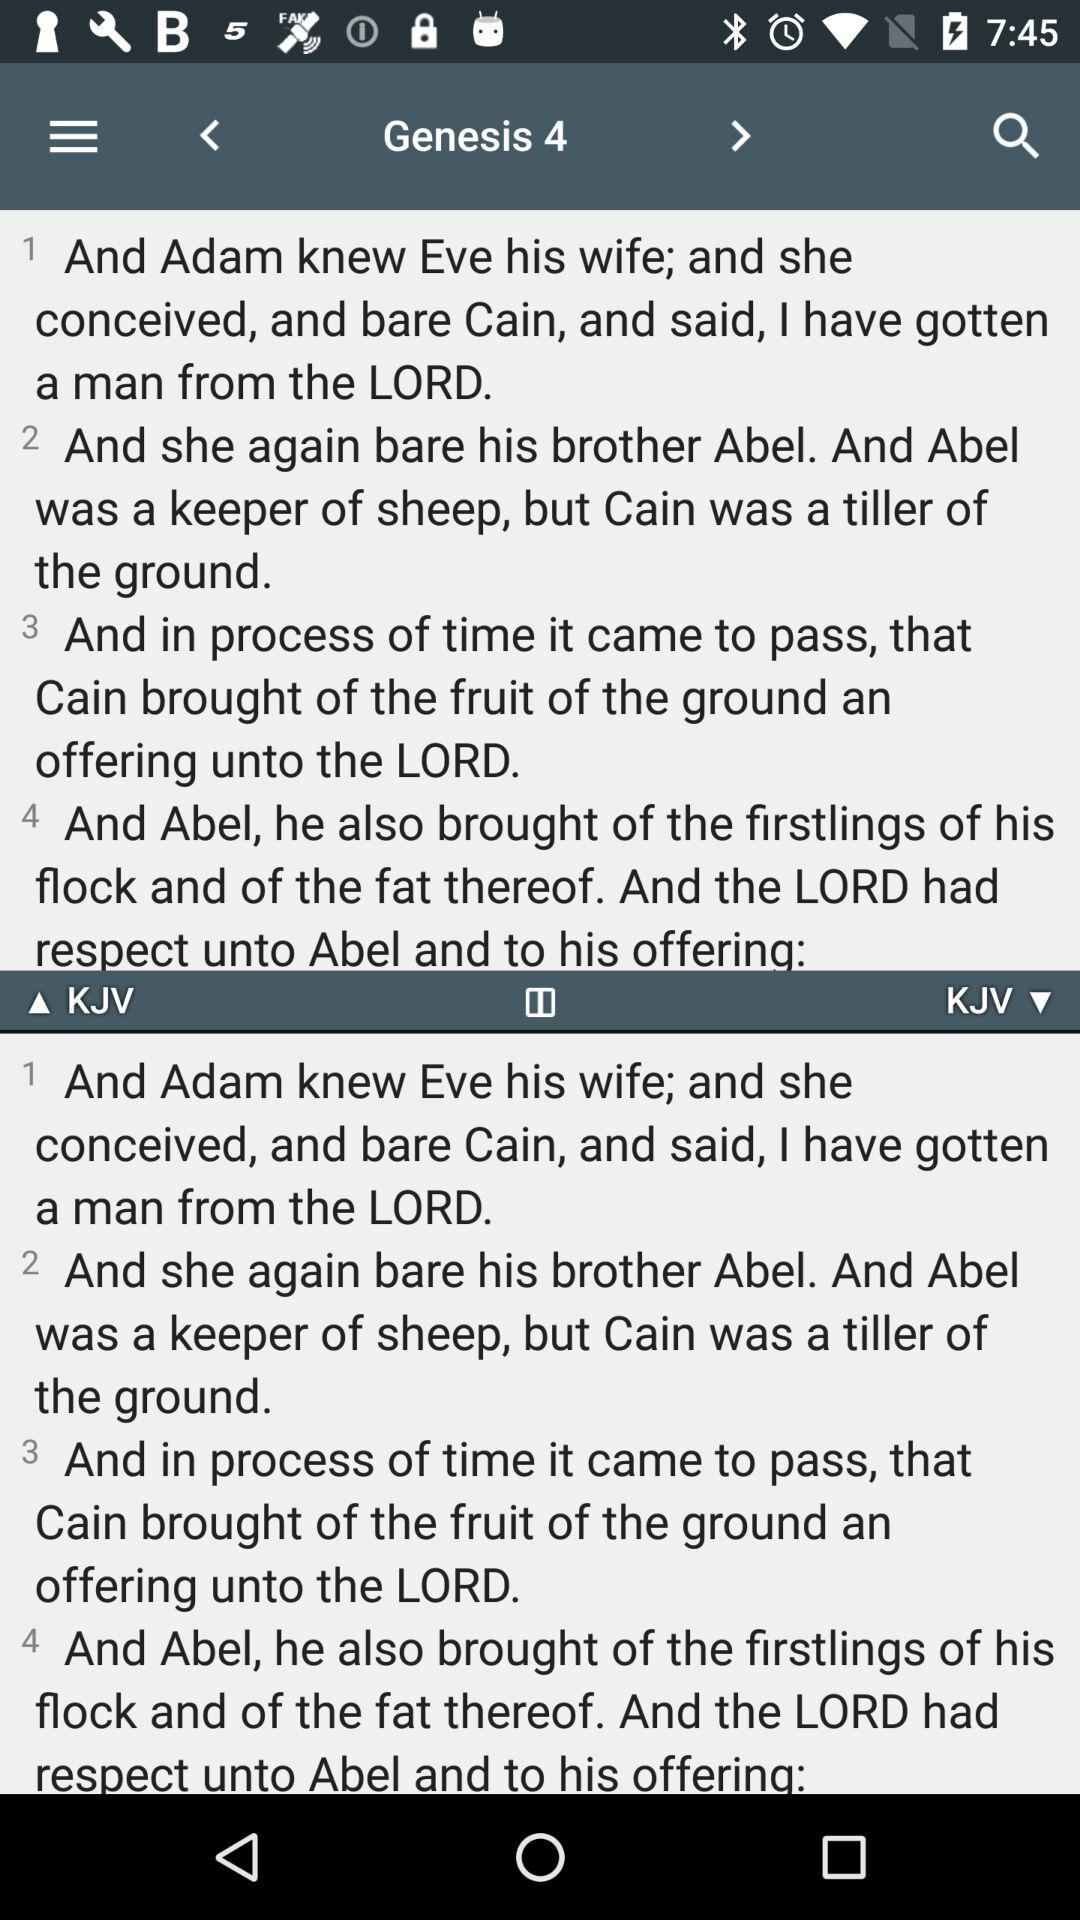Which Genesis number is currently displayed? The currently displayed Genesis number is 4. 